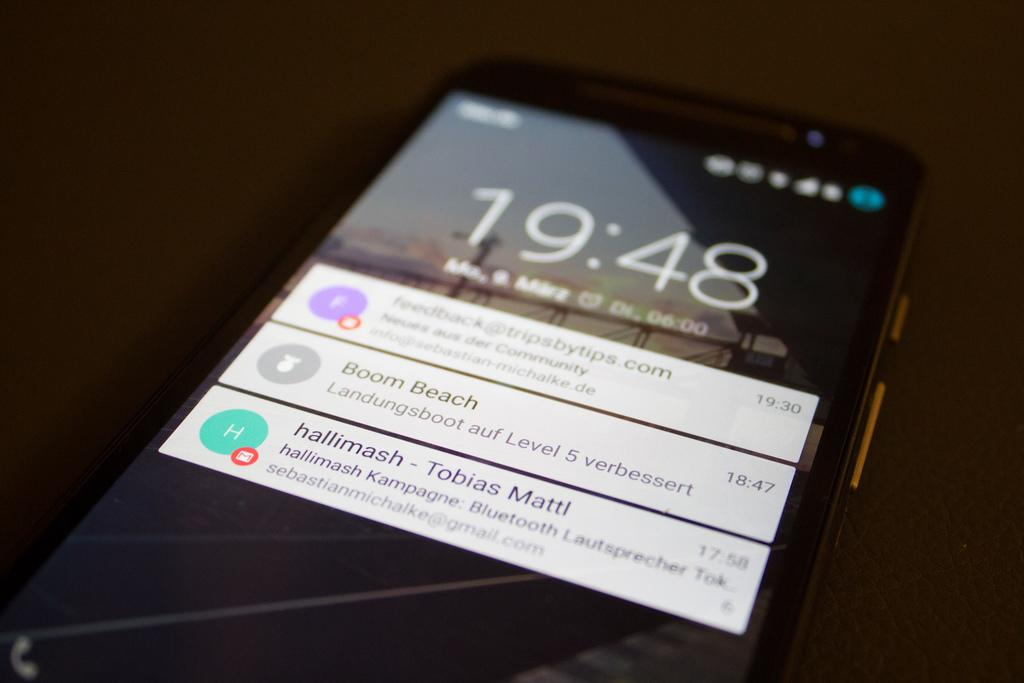<image>
Relay a brief, clear account of the picture shown. A black smartphone is showing all the notifications at 19:48 